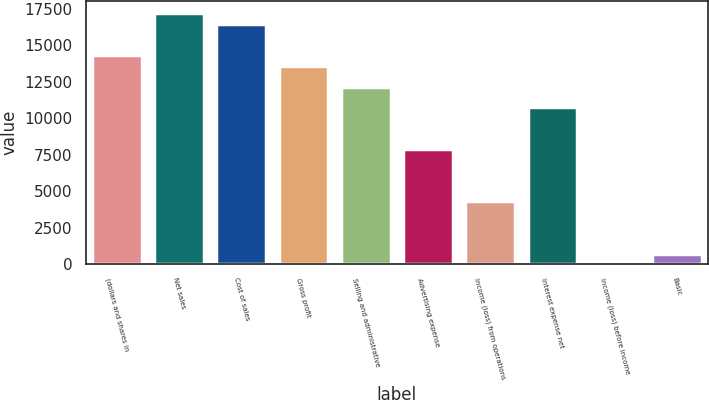<chart> <loc_0><loc_0><loc_500><loc_500><bar_chart><fcel>(dollars and shares in<fcel>Net sales<fcel>Cost of sales<fcel>Gross profit<fcel>Selling and administrative<fcel>Advertising expense<fcel>Income (loss) from operations<fcel>Interest expense net<fcel>Income (loss) before income<fcel>Basic<nl><fcel>14322.8<fcel>17186.9<fcel>16470.9<fcel>13606.8<fcel>12174.7<fcel>7878.62<fcel>4298.52<fcel>10742.7<fcel>2.4<fcel>718.42<nl></chart> 